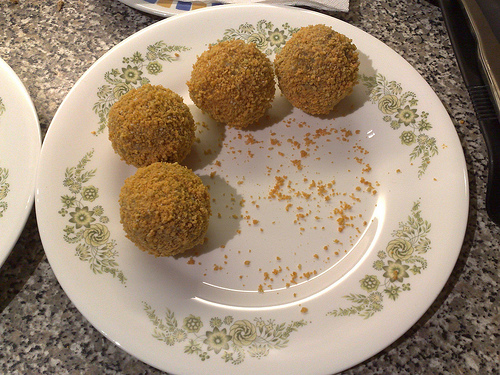<image>
Is the sweet ball next to the plate? No. The sweet ball is not positioned next to the plate. They are located in different areas of the scene. 